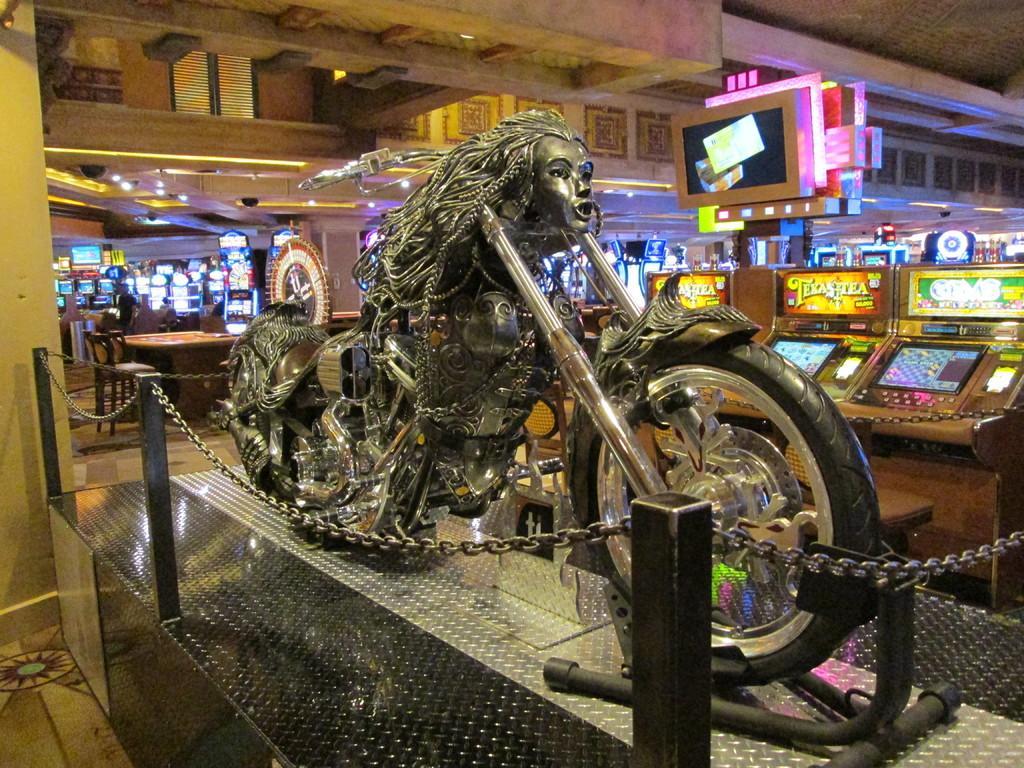Please provide a concise description of this image. In the image there is a vehicle and around that vehicle there is a chain fencing, behind that there are many gaming zones. 